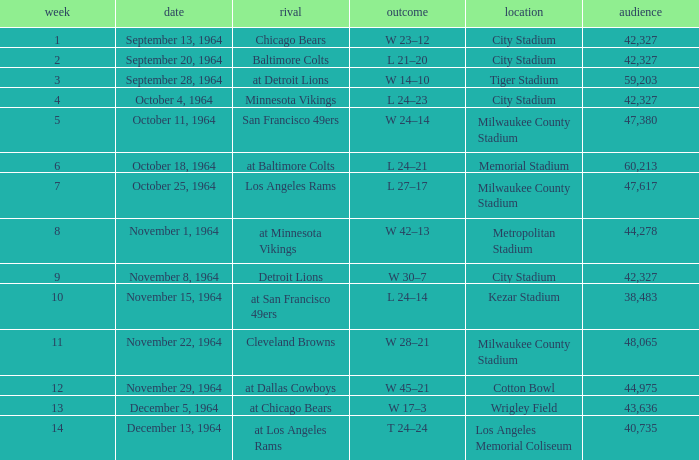What venue held that game with a result of l 24–14? Kezar Stadium. 